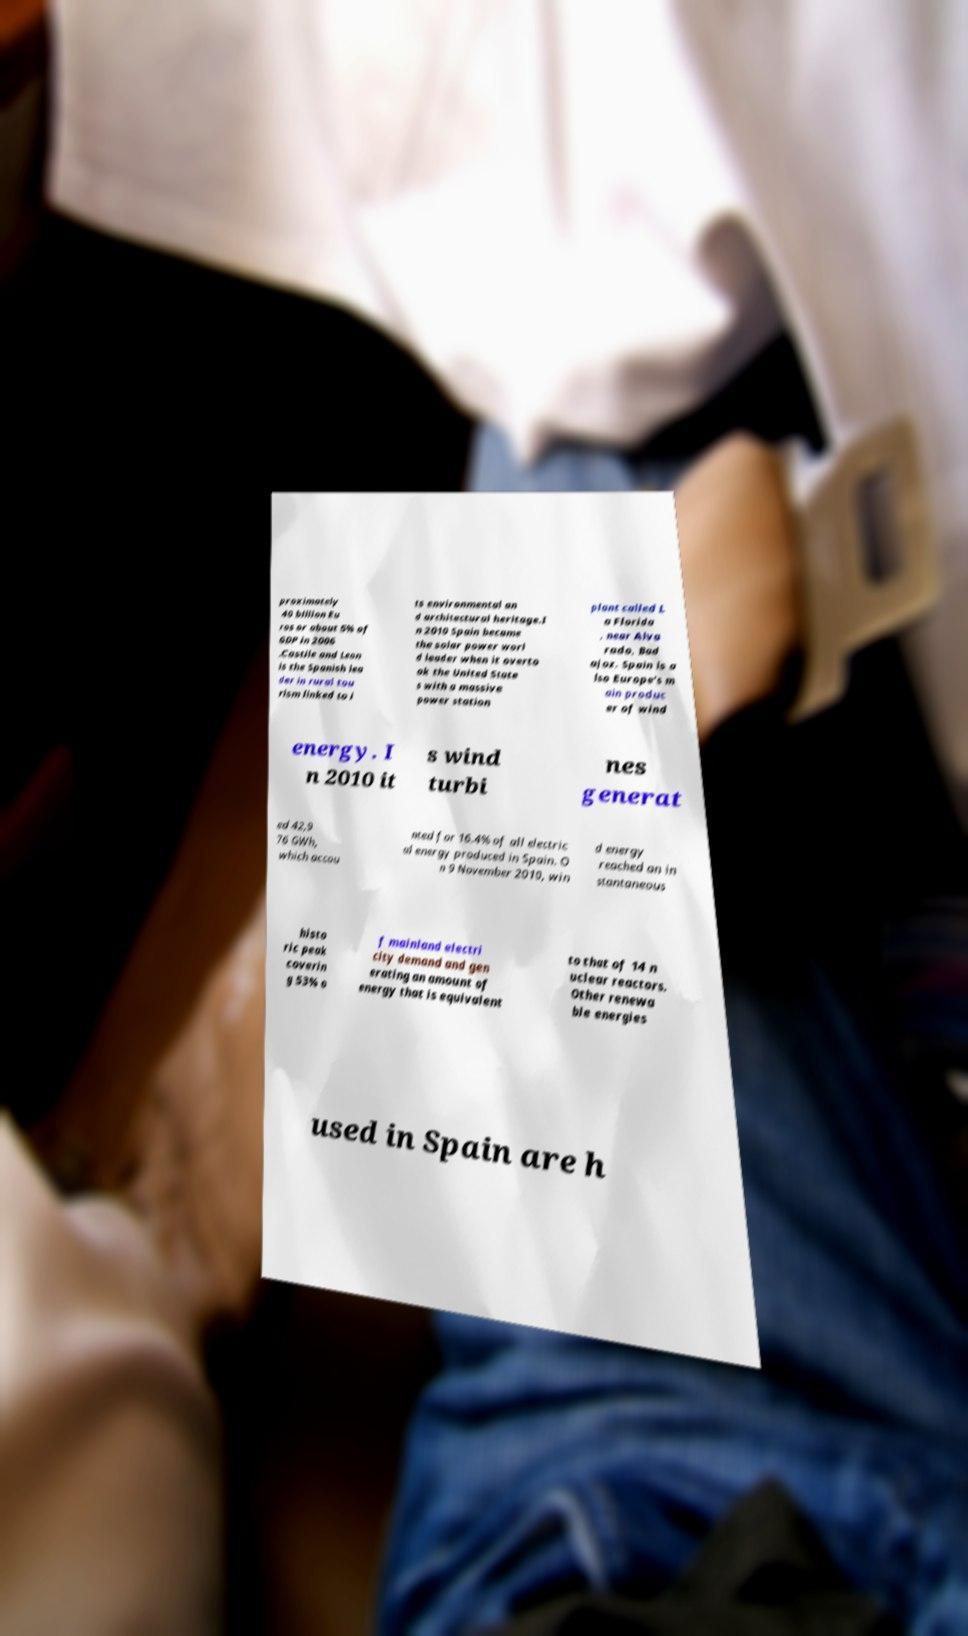Could you extract and type out the text from this image? proximately 40 billion Eu ros or about 5% of GDP in 2006 .Castile and Leon is the Spanish lea der in rural tou rism linked to i ts environmental an d architectural heritage.I n 2010 Spain became the solar power worl d leader when it overto ok the United State s with a massive power station plant called L a Florida , near Alva rado, Bad ajoz. Spain is a lso Europe's m ain produc er of wind energy. I n 2010 it s wind turbi nes generat ed 42,9 76 GWh, which accou nted for 16.4% of all electric al energy produced in Spain. O n 9 November 2010, win d energy reached an in stantaneous histo ric peak coverin g 53% o f mainland electri city demand and gen erating an amount of energy that is equivalent to that of 14 n uclear reactors. Other renewa ble energies used in Spain are h 